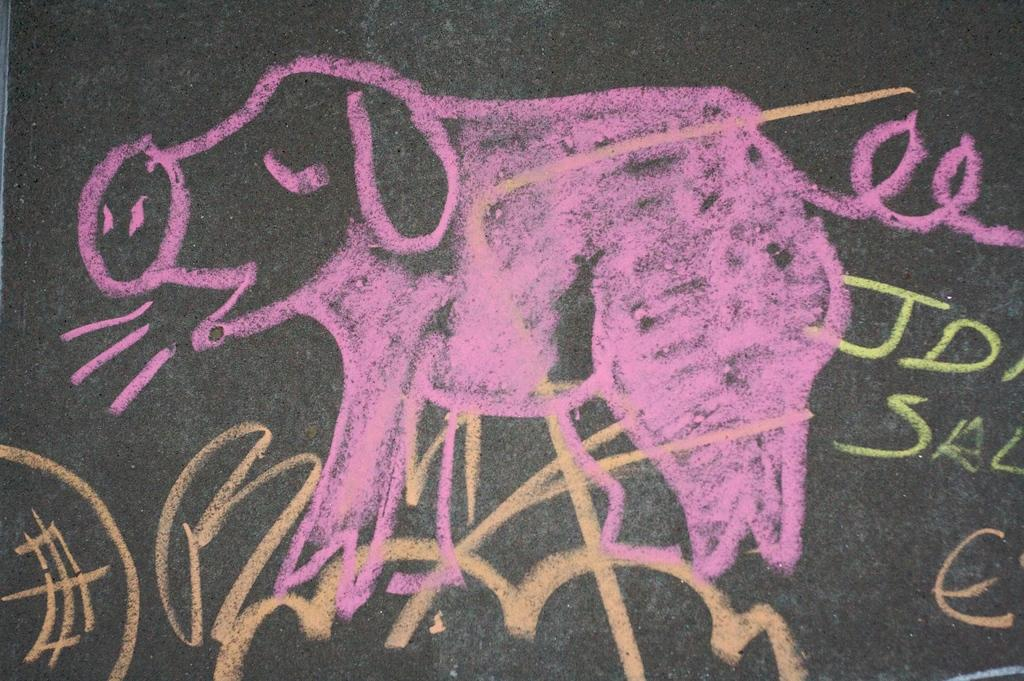What is depicted in the image? There is a drawing of an animal in the image. What color is the background of the image? The background of the image is black. What type of trip is the animal taking in the image? There is no indication of a trip in the image; it only shows a drawing of an animal with a black background. 